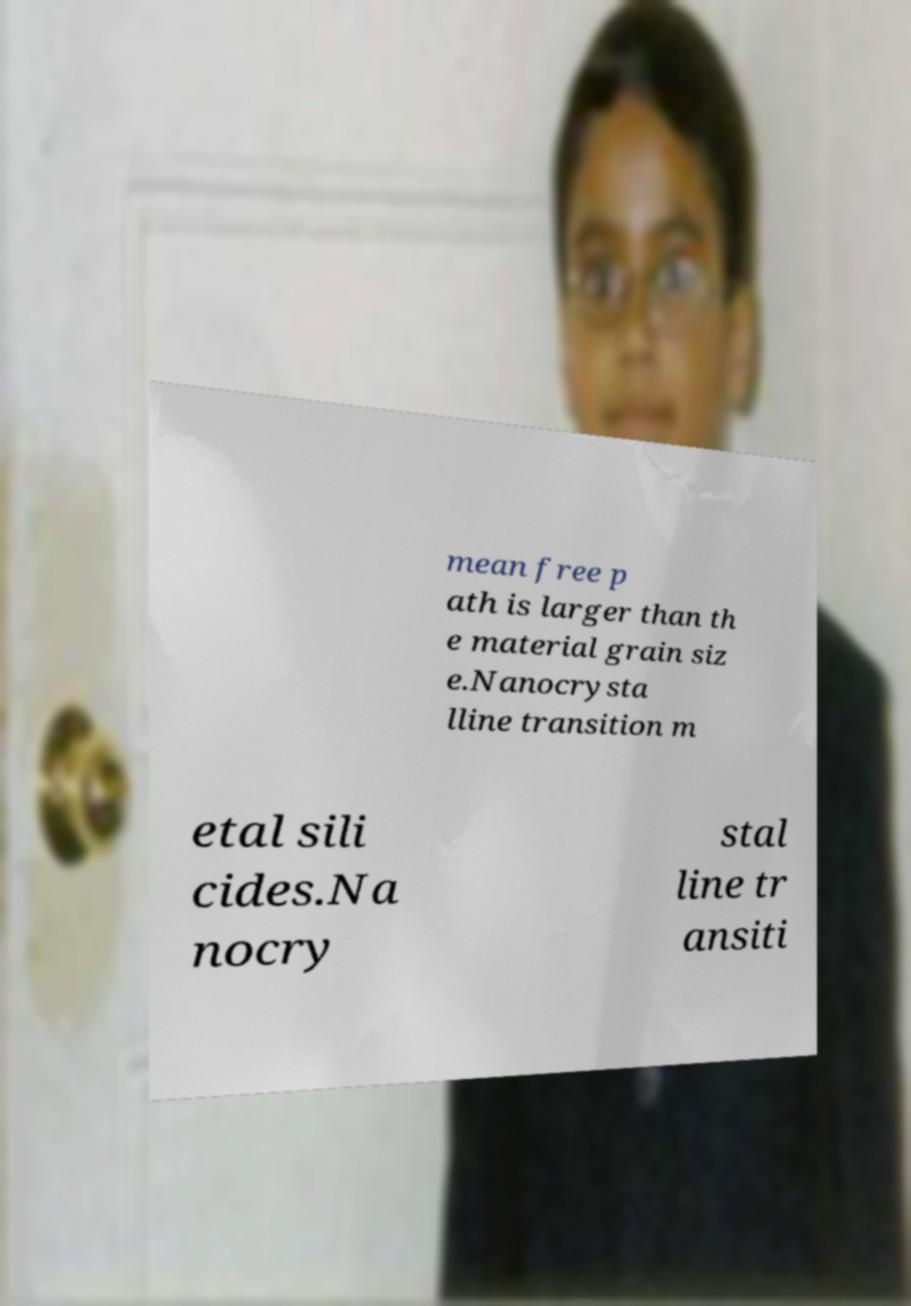I need the written content from this picture converted into text. Can you do that? mean free p ath is larger than th e material grain siz e.Nanocrysta lline transition m etal sili cides.Na nocry stal line tr ansiti 